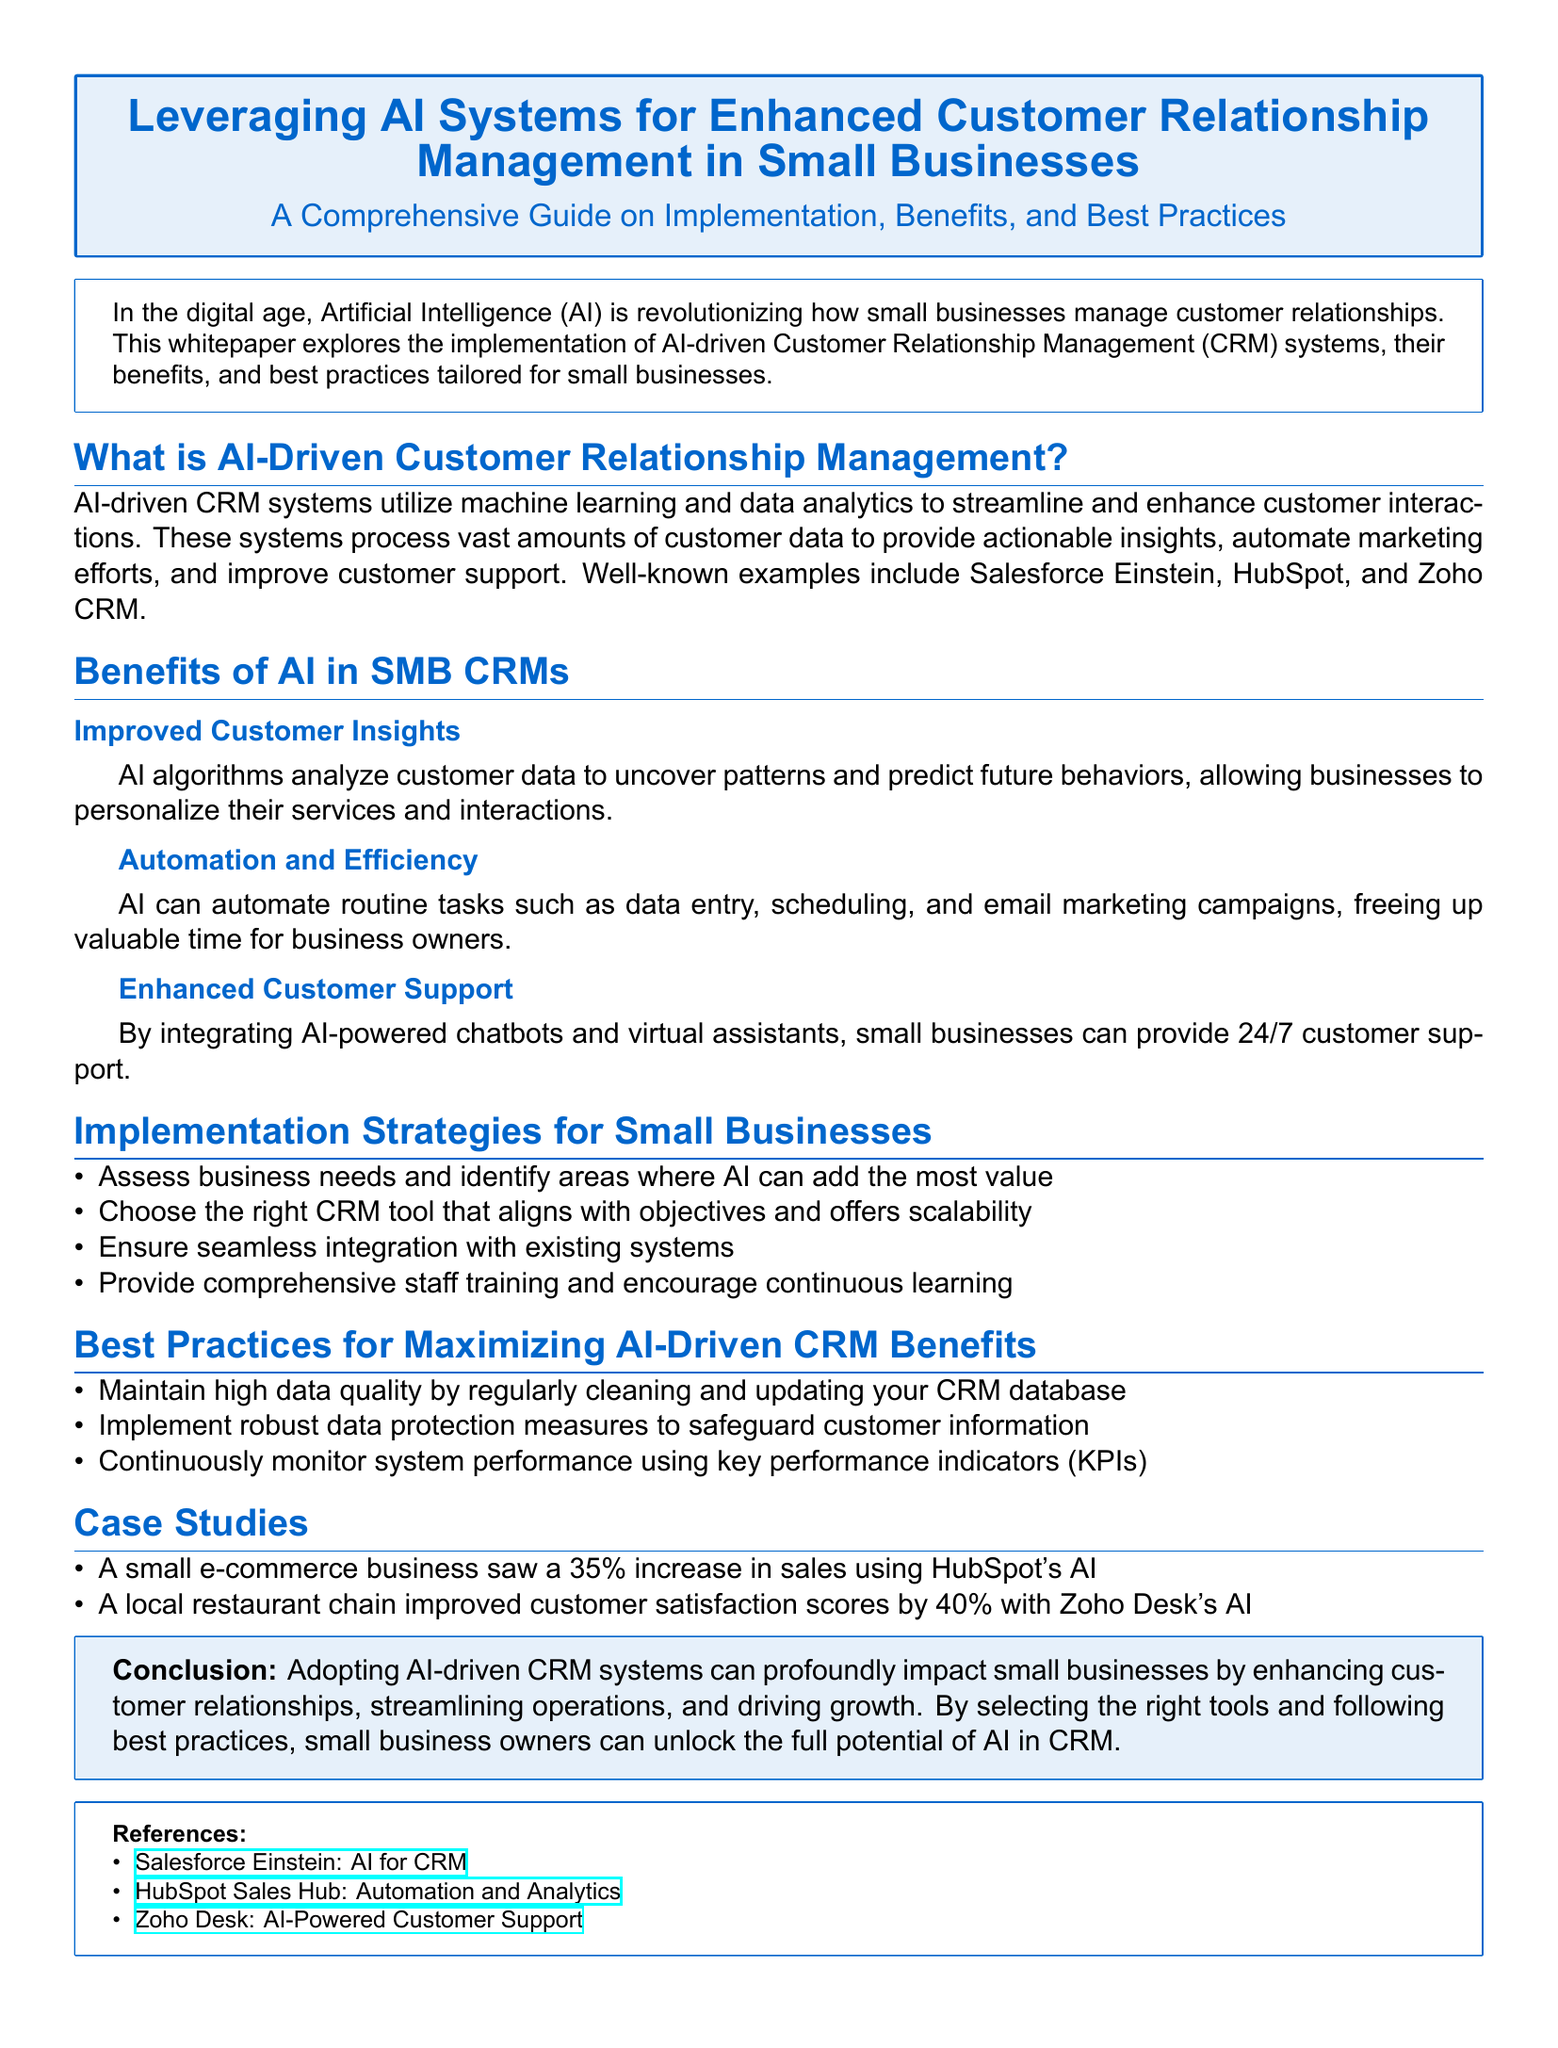What is AI-driven CRM? AI-driven CRM systems utilize machine learning and data analytics to streamline and enhance customer interactions.
Answer: AI-driven CRM systems What is one benefit of AI in SMB CRMs? The document lists several benefits; one of them is improved customer insights.
Answer: Improved customer insights What percentage increase in sales did the e-commerce business experience? The whitepaper mentions a 35% increase in sales for a small e-commerce business using HubSpot's AI.
Answer: 35% What is a key implementation strategy for small businesses? The text suggests assessing business needs and identifying areas where AI can add value as a key strategy.
Answer: Assess business needs What is one best practice for maximizing AI-driven CRM benefits? The document recommends maintaining high data quality by regularly cleaning and updating the CRM database.
Answer: Maintain high data quality Which CRM tool is mentioned as being used by a local restaurant chain? The whitepaper states that the local restaurant chain improved its customer satisfaction scores using Zoho Desk's AI.
Answer: Zoho Desk What kind of customer support can small businesses provide with AI? The implementation of AI-powered chatbots and virtual assistants allows businesses to provide 24/7 customer support.
Answer: 24/7 customer support What is the conclusion about AI-driven CRM systems? The conclusion states that adopting AI-driven CRM systems can profoundly impact small businesses.
Answer: Profoundly impact small businesses 